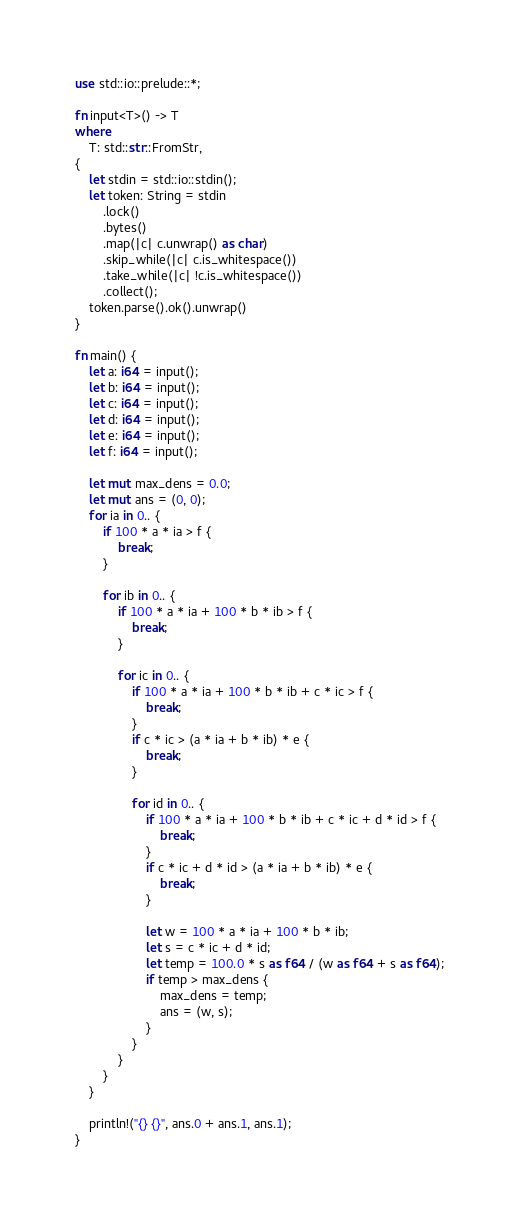<code> <loc_0><loc_0><loc_500><loc_500><_Rust_>use std::io::prelude::*;

fn input<T>() -> T
where
    T: std::str::FromStr,
{
    let stdin = std::io::stdin();
    let token: String = stdin
        .lock()
        .bytes()
        .map(|c| c.unwrap() as char)
        .skip_while(|c| c.is_whitespace())
        .take_while(|c| !c.is_whitespace())
        .collect();
    token.parse().ok().unwrap()
}

fn main() {
    let a: i64 = input();
    let b: i64 = input();
    let c: i64 = input();
    let d: i64 = input();
    let e: i64 = input();
    let f: i64 = input();

    let mut max_dens = 0.0;
    let mut ans = (0, 0);
    for ia in 0.. {
        if 100 * a * ia > f {
            break;
        }

        for ib in 0.. {
            if 100 * a * ia + 100 * b * ib > f {
                break;
            }

            for ic in 0.. {
                if 100 * a * ia + 100 * b * ib + c * ic > f {
                    break;
                }
                if c * ic > (a * ia + b * ib) * e {
                    break;
                }

                for id in 0.. {
                    if 100 * a * ia + 100 * b * ib + c * ic + d * id > f {
                        break;
                    }
                    if c * ic + d * id > (a * ia + b * ib) * e {
                        break;
                    }

                    let w = 100 * a * ia + 100 * b * ib;
                    let s = c * ic + d * id;
                    let temp = 100.0 * s as f64 / (w as f64 + s as f64);
                    if temp > max_dens {
                        max_dens = temp;
                        ans = (w, s);
                    }
                }
            }
        }
    }

    println!("{} {}", ans.0 + ans.1, ans.1);
}
</code> 